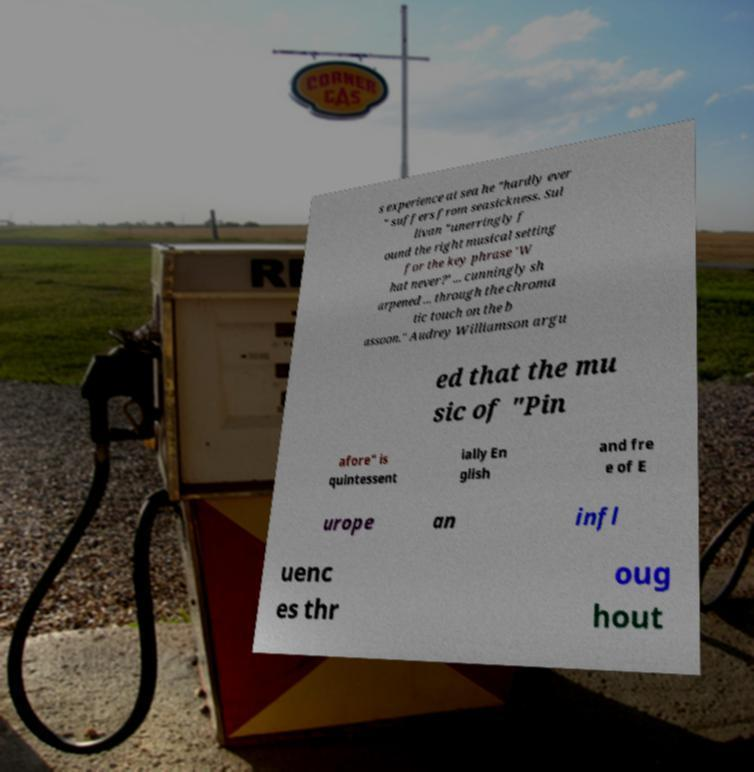Could you assist in decoding the text presented in this image and type it out clearly? s experience at sea he "hardly ever " suffers from seasickness. Sul livan "unerringly f ound the right musical setting for the key phrase 'W hat never?' ... cunningly sh arpened ... through the chroma tic touch on the b assoon." Audrey Williamson argu ed that the mu sic of "Pin afore" is quintessent ially En glish and fre e of E urope an infl uenc es thr oug hout 